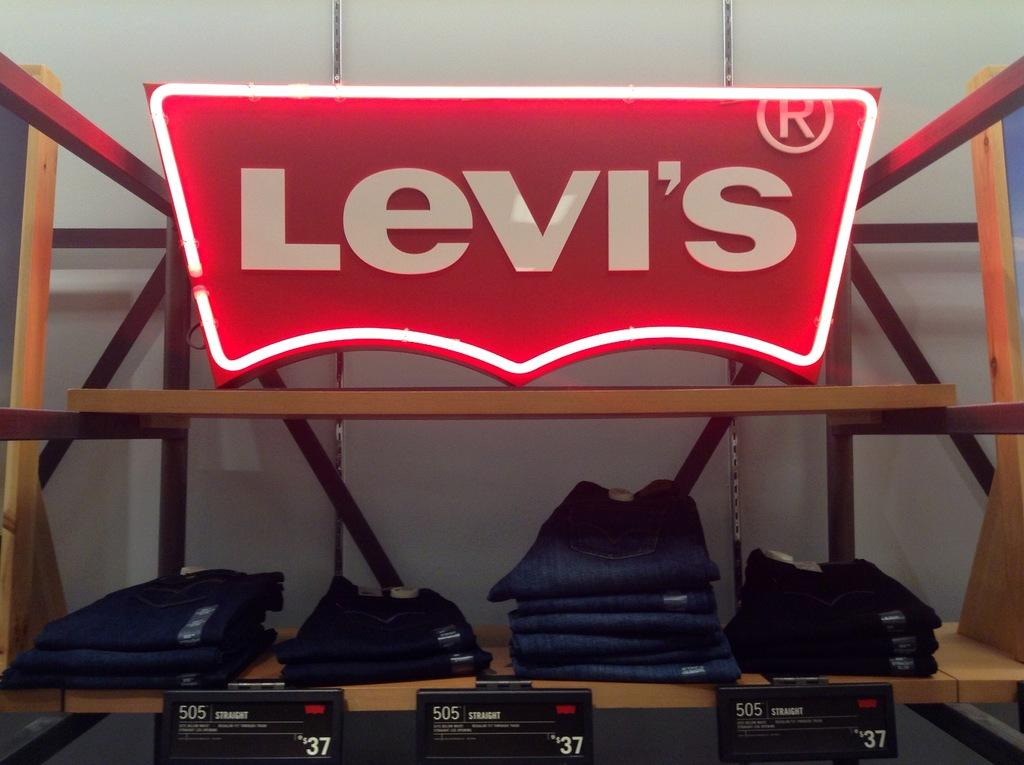What is placed on the shelf in the image? There are genes on the shelf in the image. What can be seen on the top and bottom sides of the image? There are boards on the top and bottom sides of the image. What is written on the boards? Something is written on the boards, but the specific content is not mentioned in the facts. Can you see a tiger blowing a spot in the image? No, there is no tiger or spot present in the image. 